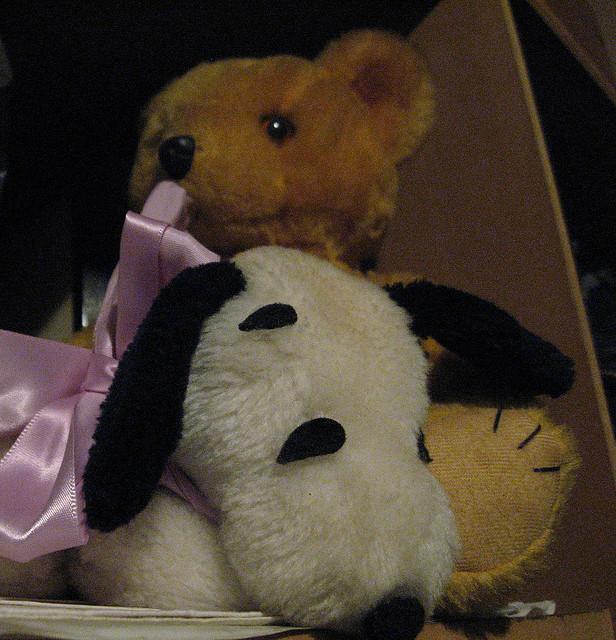What is the largest animal?
Be succinct. Dog. What kind of animal is this?
Keep it brief. Dog. What color is the bear?
Short answer required. Brown. Are these bears reading?
Write a very short answer. No. Does the bear look out of place?
Be succinct. No. Is this bear happy?
Write a very short answer. Yes. What is in front of the teddy bear?
Quick response, please. Snoopy. Does the bear have a hat?
Concise answer only. No. Why does animal have long head?
Short answer required. Snoopy. If the first animal on the right was real, what would it eat?
Answer briefly. Meat. What color is the teddy bear?
Answer briefly. Brown. What color are the teddy bears?
Write a very short answer. Brown. What color bow is on the dog?
Concise answer only. Pink. Is there a stuffed cow?
Quick response, please. No. What is the dog wearing?
Answer briefly. Bow. What color are the bears?
Concise answer only. Brown. What kind of stuffed animals are these?
Write a very short answer. Dog and bear. Does the bear love you?
Concise answer only. No. What kind of animal is the stuffed toy in the lower center of the picture?
Quick response, please. Dog. Is anyone playing with the stuffed animals?
Be succinct. No. What color is the car left of the bear?
Short answer required. No car. What comic character is the white dog meant to be?
Answer briefly. Snoopy. What kind of animal is on top?
Be succinct. Bear. Is the bear fuzzy?
Be succinct. Yes. Do you see any angel statues?
Answer briefly. No. 